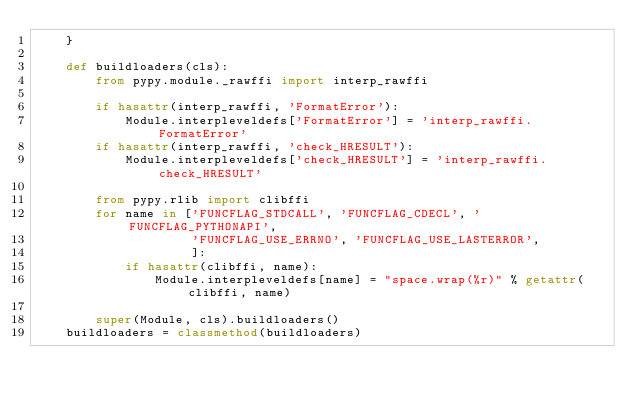Convert code to text. <code><loc_0><loc_0><loc_500><loc_500><_Python_>    }

    def buildloaders(cls):
        from pypy.module._rawffi import interp_rawffi

        if hasattr(interp_rawffi, 'FormatError'):
            Module.interpleveldefs['FormatError'] = 'interp_rawffi.FormatError'
        if hasattr(interp_rawffi, 'check_HRESULT'):
            Module.interpleveldefs['check_HRESULT'] = 'interp_rawffi.check_HRESULT'

        from pypy.rlib import clibffi
        for name in ['FUNCFLAG_STDCALL', 'FUNCFLAG_CDECL', 'FUNCFLAG_PYTHONAPI',
                     'FUNCFLAG_USE_ERRNO', 'FUNCFLAG_USE_LASTERROR',
                     ]:
            if hasattr(clibffi, name):
                Module.interpleveldefs[name] = "space.wrap(%r)" % getattr(clibffi, name)
                
        super(Module, cls).buildloaders()
    buildloaders = classmethod(buildloaders)
</code> 